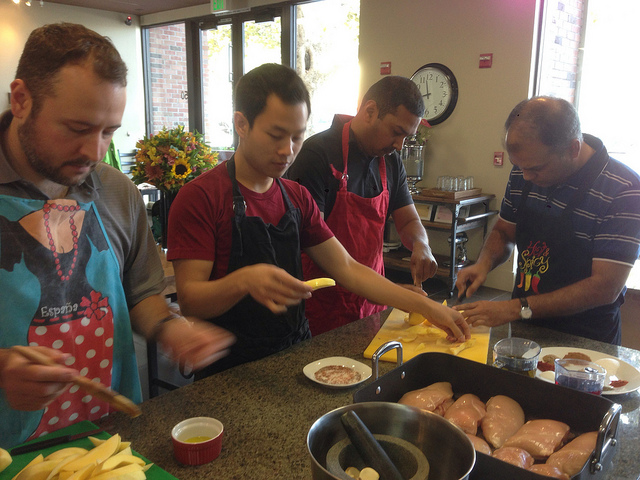What kind of setting does this activity take place in? The group is in a well-lit, casual kitchen environment, which is likely a cooking class or a communal kitchen due to the organized setup and multiple participants involved in the cooking process. 